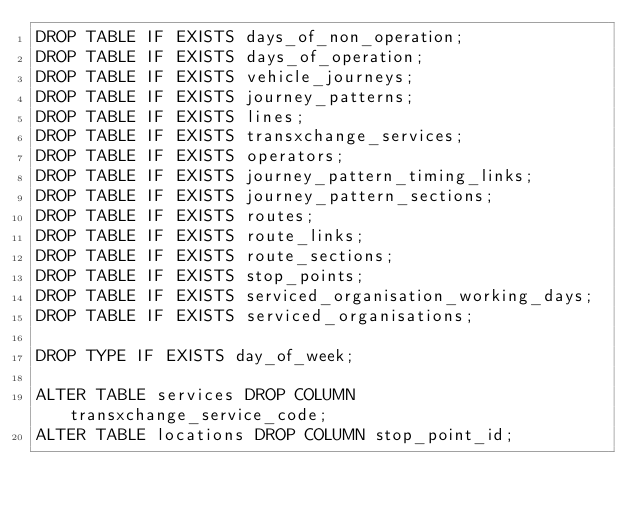<code> <loc_0><loc_0><loc_500><loc_500><_SQL_>DROP TABLE IF EXISTS days_of_non_operation;
DROP TABLE IF EXISTS days_of_operation;
DROP TABLE IF EXISTS vehicle_journeys;
DROP TABLE IF EXISTS journey_patterns;
DROP TABLE IF EXISTS lines;
DROP TABLE IF EXISTS transxchange_services;
DROP TABLE IF EXISTS operators;
DROP TABLE IF EXISTS journey_pattern_timing_links;
DROP TABLE IF EXISTS journey_pattern_sections;
DROP TABLE IF EXISTS routes;
DROP TABLE IF EXISTS route_links;
DROP TABLE IF EXISTS route_sections;
DROP TABLE IF EXISTS stop_points;
DROP TABLE IF EXISTS serviced_organisation_working_days;
DROP TABLE IF EXISTS serviced_organisations;

DROP TYPE IF EXISTS day_of_week;

ALTER TABLE services DROP COLUMN transxchange_service_code;
ALTER TABLE locations DROP COLUMN stop_point_id;</code> 